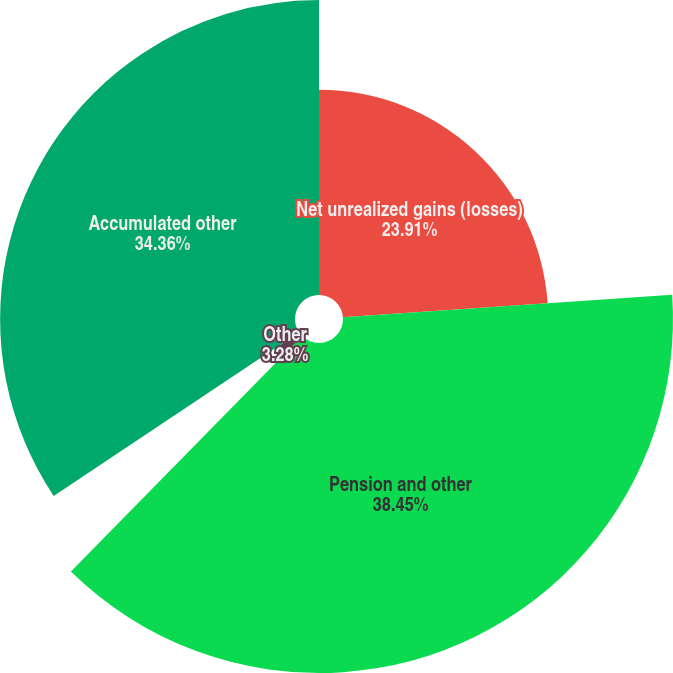<chart> <loc_0><loc_0><loc_500><loc_500><pie_chart><fcel>Net unrealized gains (losses)<fcel>Pension and other<fcel>Other<fcel>Accumulated other<nl><fcel>23.91%<fcel>38.45%<fcel>3.28%<fcel>34.36%<nl></chart> 